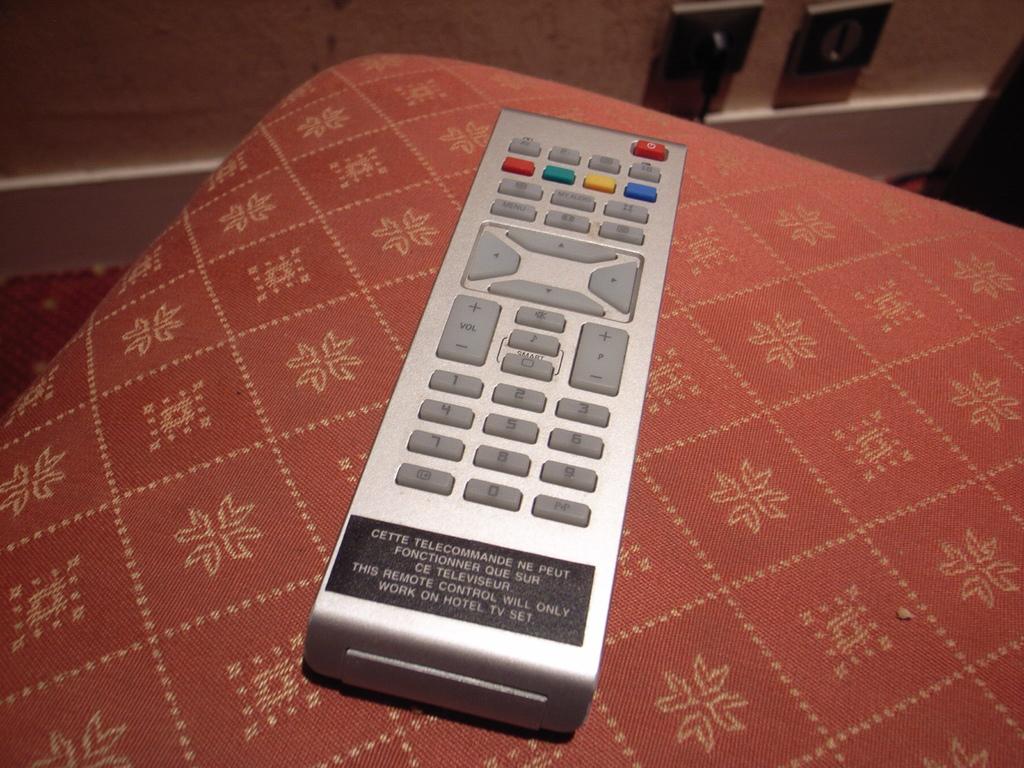Is this a hotel remote?
Give a very brief answer. Yes. 